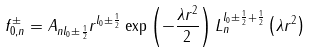Convert formula to latex. <formula><loc_0><loc_0><loc_500><loc_500>f _ { 0 , n } ^ { \pm } = A _ { n l _ { 0 } \pm \frac { 1 } { 2 } } r ^ { l _ { 0 } \pm \frac { 1 } { 2 } } \exp \left ( - \frac { \lambda r ^ { 2 } } 2 \right ) L _ { n } ^ { l _ { 0 } \pm \frac { 1 } { 2 } + \frac { 1 } { 2 } } \left ( \lambda r ^ { 2 } \right )</formula> 